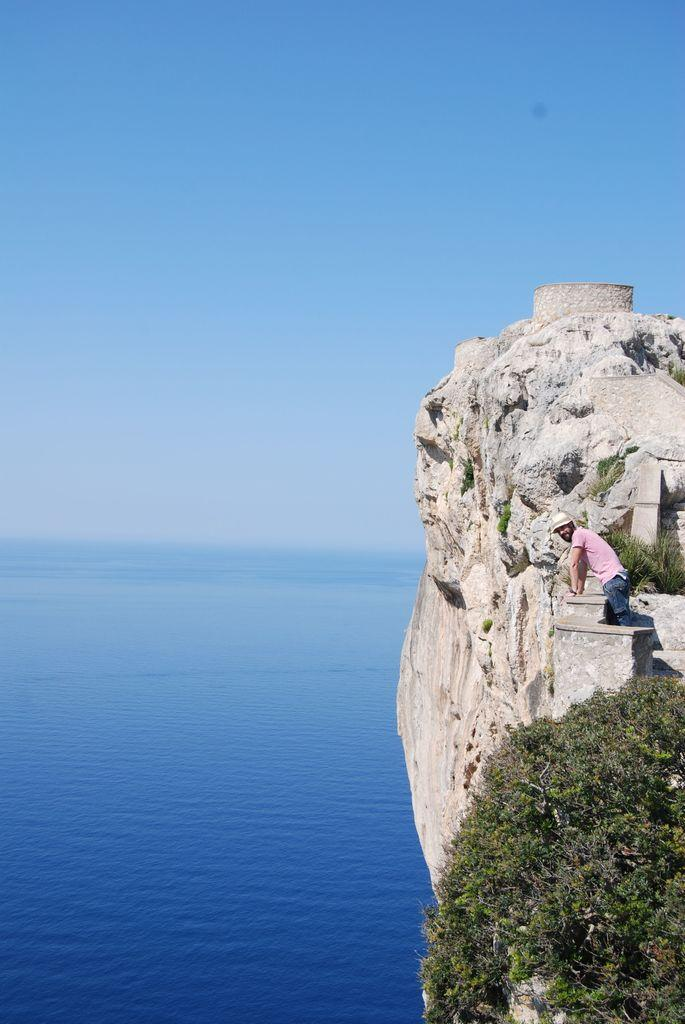What is the person in the image doing? The person is standing at a hill in the image. What type of vegetation can be seen in the image? There are trees in the image. What natural feature is visible in the distance? There is an ocean visible in the image. What part of the sky is visible in the image? The sky is visible in the image. What type of engine can be seen powering the rat in the image? There is no rat or engine present in the image. 